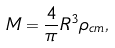Convert formula to latex. <formula><loc_0><loc_0><loc_500><loc_500>M = \frac { 4 } { \pi } R ^ { 3 } \rho _ { c m } ,</formula> 